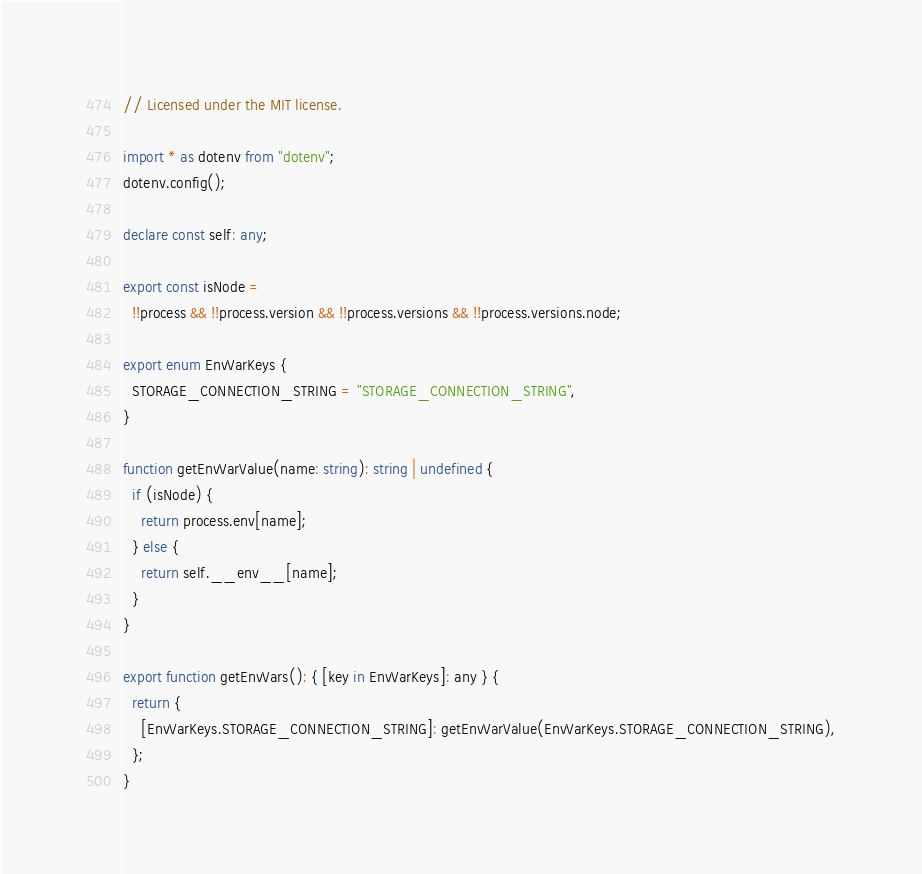<code> <loc_0><loc_0><loc_500><loc_500><_TypeScript_>// Licensed under the MIT license.

import * as dotenv from "dotenv";
dotenv.config();

declare const self: any;

export const isNode =
  !!process && !!process.version && !!process.versions && !!process.versions.node;

export enum EnvVarKeys {
  STORAGE_CONNECTION_STRING = "STORAGE_CONNECTION_STRING",
}

function getEnvVarValue(name: string): string | undefined {
  if (isNode) {
    return process.env[name];
  } else {
    return self.__env__[name];
  }
}

export function getEnvVars(): { [key in EnvVarKeys]: any } {
  return {
    [EnvVarKeys.STORAGE_CONNECTION_STRING]: getEnvVarValue(EnvVarKeys.STORAGE_CONNECTION_STRING),
  };
}
</code> 